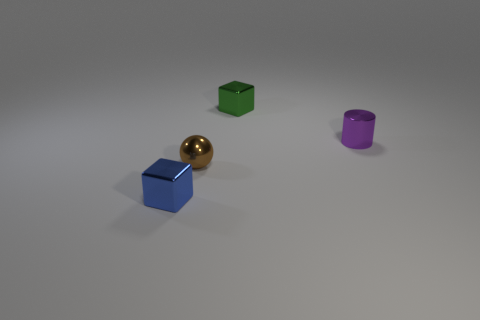Are the green thing and the cube that is on the left side of the small green object made of the same material?
Your answer should be compact. Yes. How many yellow metal balls are there?
Make the answer very short. 0. How big is the block that is in front of the small cylinder?
Offer a terse response. Small. How many other rubber things are the same size as the green object?
Make the answer very short. 0. What is the object that is left of the green object and on the right side of the blue block made of?
Offer a very short reply. Metal. What size is the metallic cube right of the cube left of the block behind the small ball?
Your response must be concise. Small. What is the size of the blue block that is the same material as the cylinder?
Make the answer very short. Small. There is a sphere; is it the same size as the thing that is behind the tiny purple object?
Your answer should be very brief. Yes. What is the shape of the small metallic object behind the small metallic cylinder?
Keep it short and to the point. Cube. Is there a thing that is on the right side of the small metallic block that is in front of the metallic ball that is in front of the metal cylinder?
Ensure brevity in your answer.  Yes. 